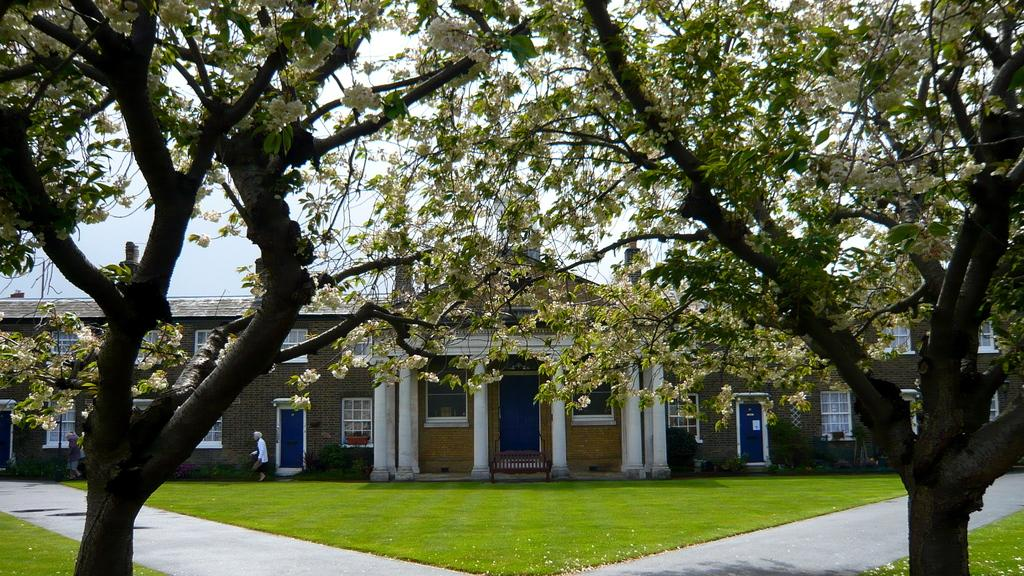What type of structure is present in the image? There is a building in the image. What type of vegetation can be seen in the image? There is grass and trees in the image. What are the people in the image doing? People are walking on the ground in the image. What can be seen in the background of the image? The sky is visible in the background of the image. How many ducks are swimming in the ice in the image? There are no ducks or ice present in the image. What type of sail is attached to the building in the image? There is no sail attached to the building in the image. 